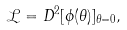Convert formula to latex. <formula><loc_0><loc_0><loc_500><loc_500>\mathcal { L } = D ^ { 2 } [ \phi ( \theta ) ] _ { \theta = 0 } ,</formula> 